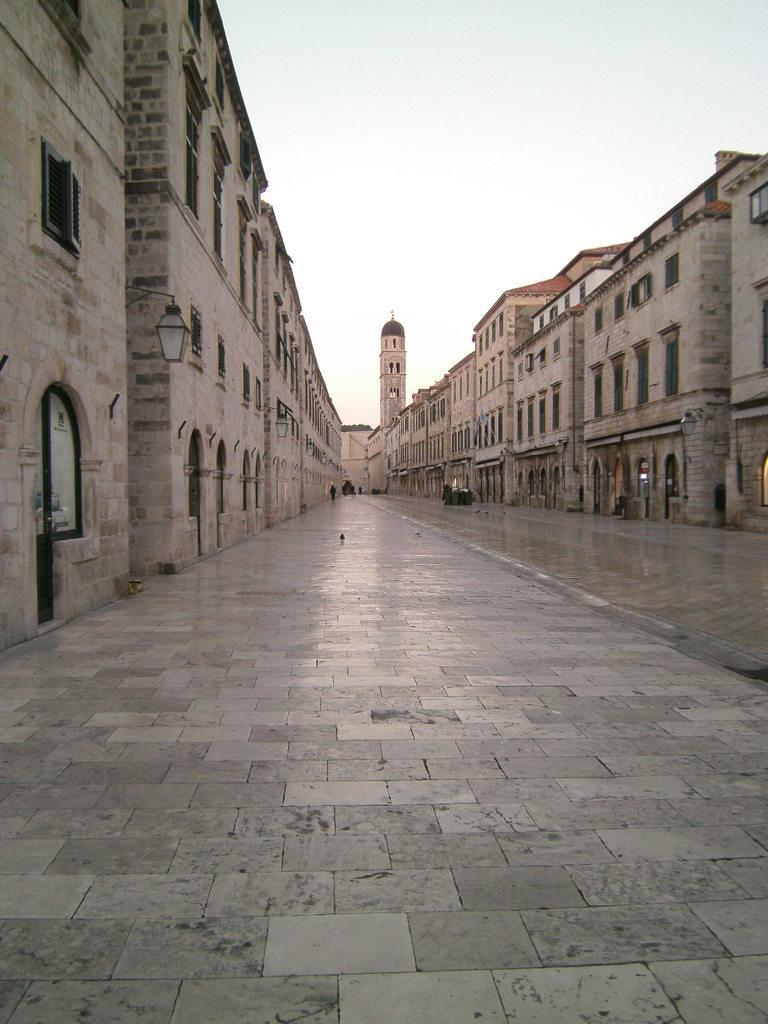Describe this image in one or two sentences. To the both sides of the image there are buildings, windows. At the bottom of the image there is pavement. At the top of the image there is sky. 